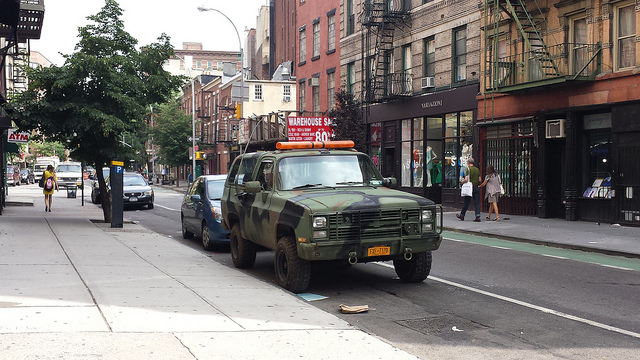What kind of vehicle is at the front, and does it look like it's for regular use? The vehicle at the front appears to be a heavily modified SUV, featuring a militaristic design. It doesn't seem to be for regular, everyday use, likely intended for specialty purposes or promotional events. 